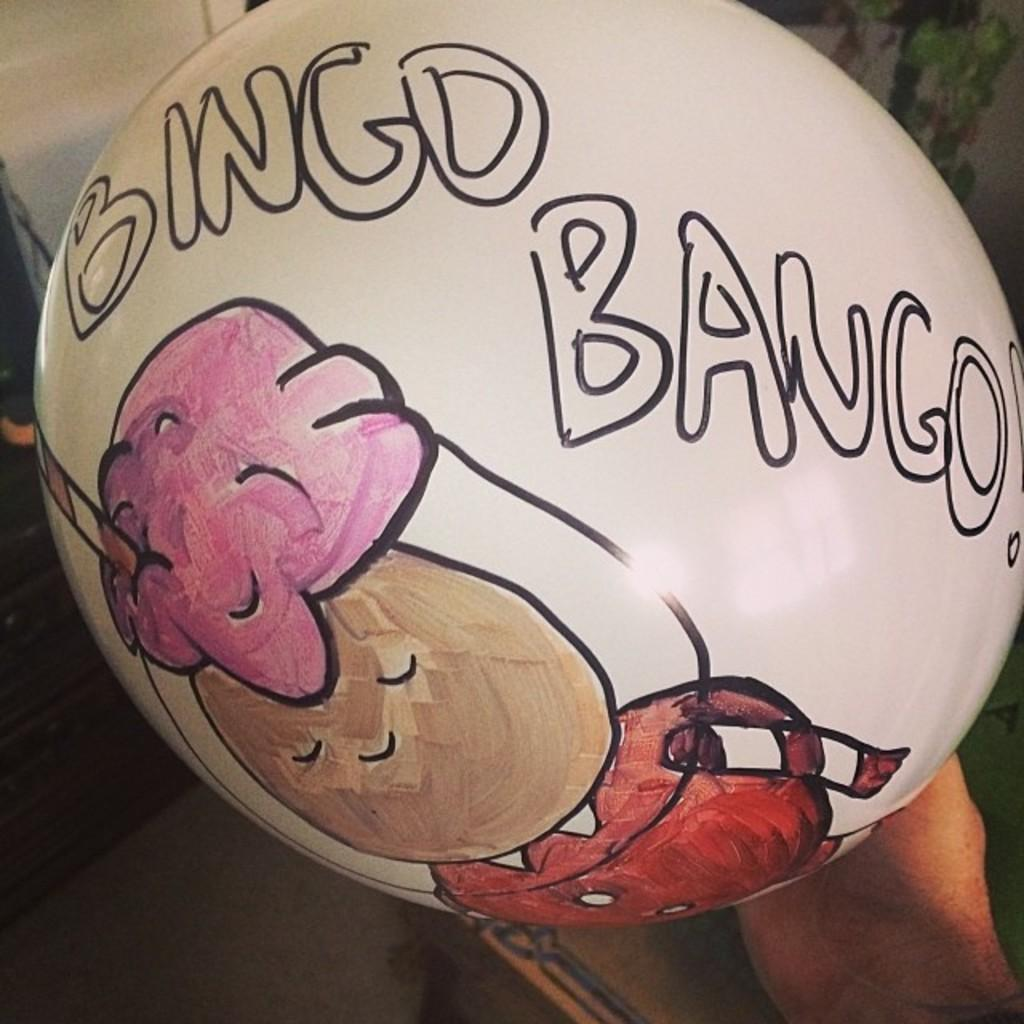What is depicted on the white balloon in the image? There is a sketch on a white balloon in the foreground of the image. Who is holding the balloon? The balloon is being held by a person. What can be seen in the background of the image? There is a floor visible in the background of the image, along with objects present. What type of record is being played in the background of the image? There is no record or music player present in the image; it only features a sketch on a white balloon being held by a person. 